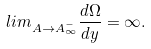<formula> <loc_0><loc_0><loc_500><loc_500>l i m _ { A \rightarrow A _ { \infty } ^ { - } } \frac { d \Omega } { d y } = \infty .</formula> 